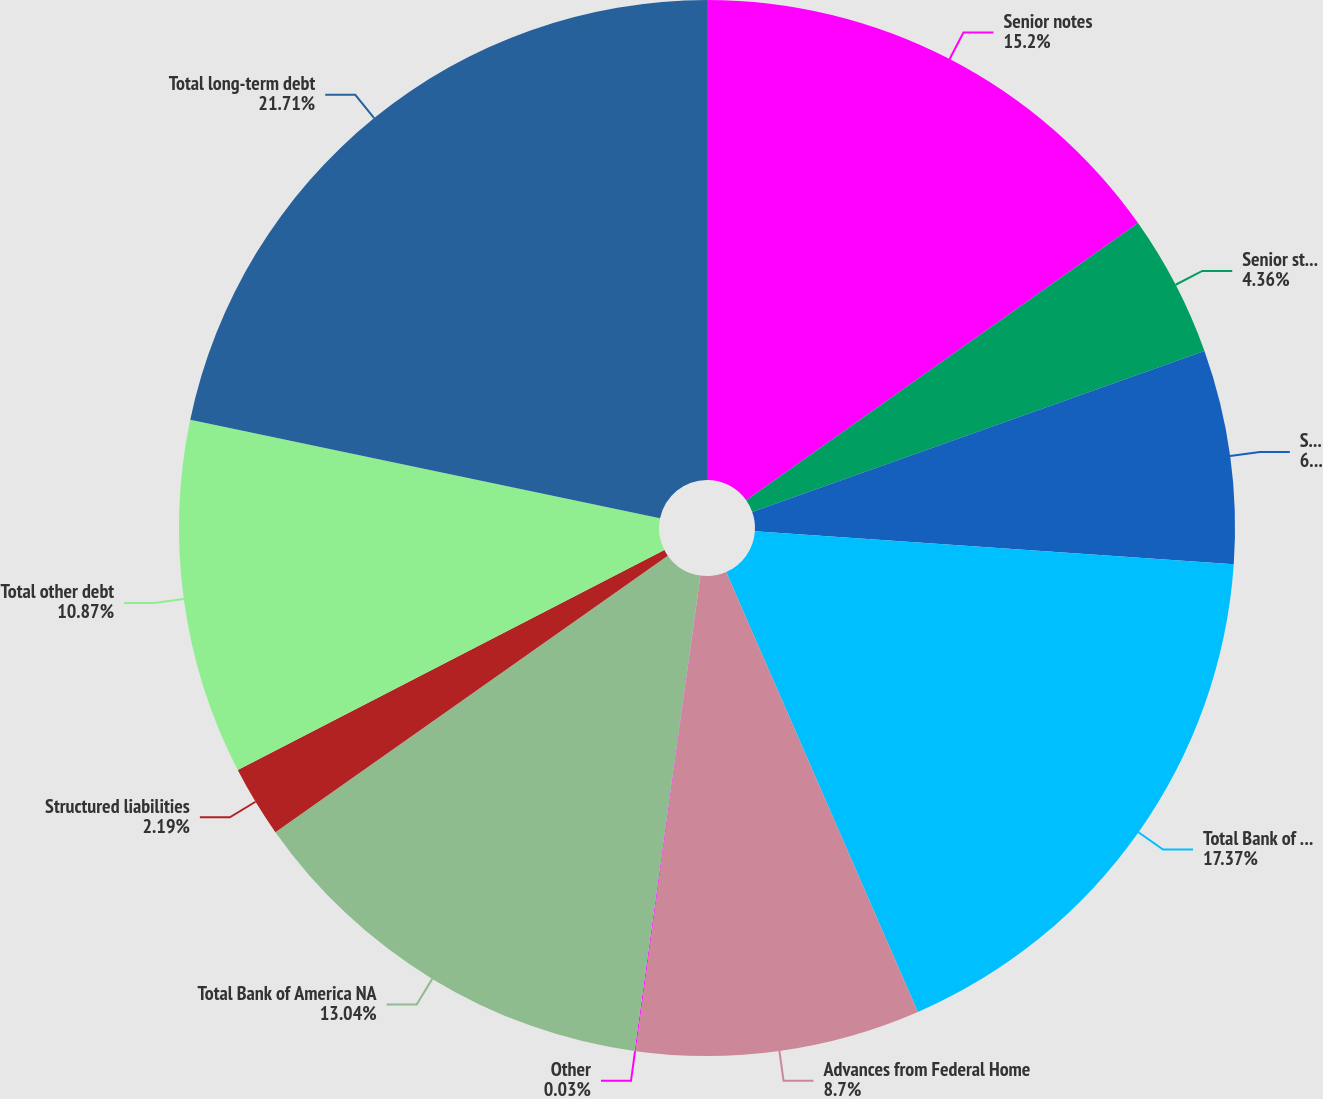Convert chart to OTSL. <chart><loc_0><loc_0><loc_500><loc_500><pie_chart><fcel>Senior notes<fcel>Senior structured notes<fcel>Subordinated notes<fcel>Total Bank of America<fcel>Advances from Federal Home<fcel>Other<fcel>Total Bank of America NA<fcel>Structured liabilities<fcel>Total other debt<fcel>Total long-term debt<nl><fcel>15.2%<fcel>4.36%<fcel>6.53%<fcel>17.37%<fcel>8.7%<fcel>0.03%<fcel>13.04%<fcel>2.19%<fcel>10.87%<fcel>21.71%<nl></chart> 